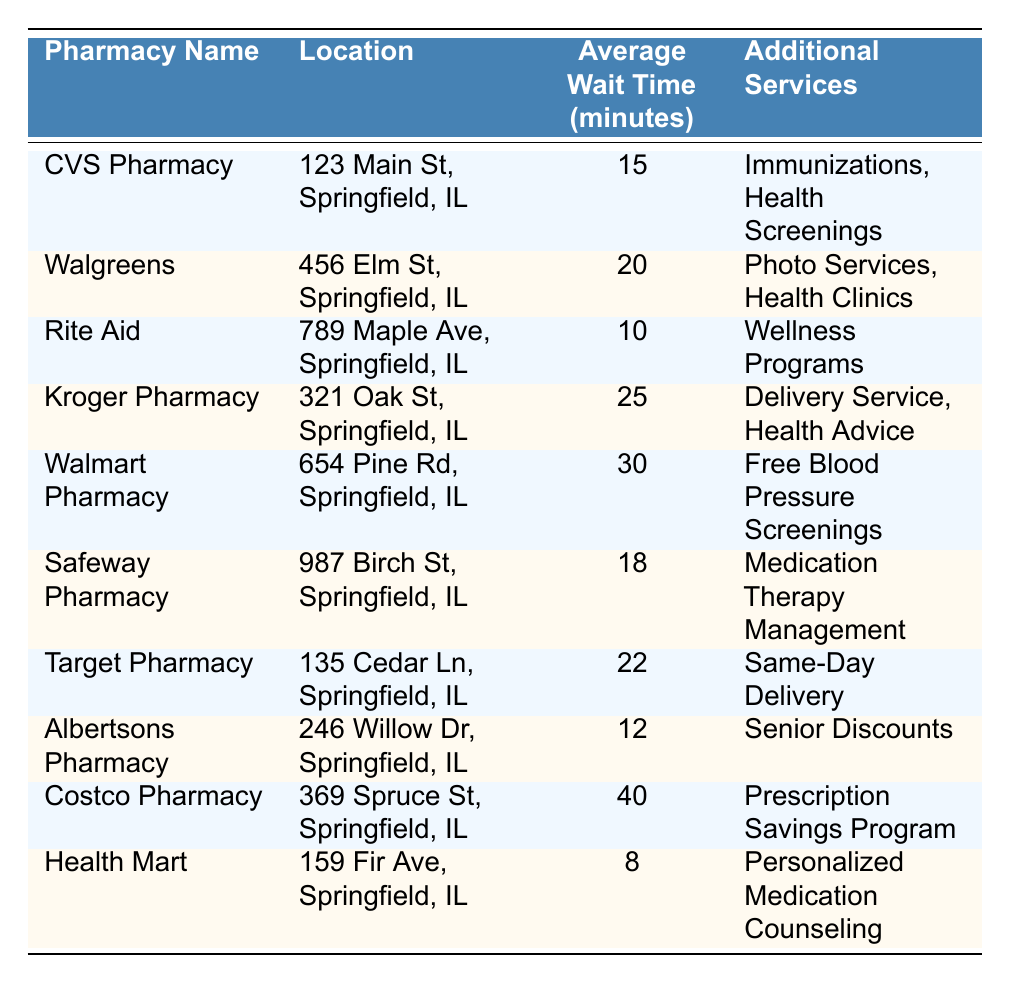What is the average wait time for picking up a prescription at Rite Aid? The table indicates that Rite Aid has an average wait time of 10 minutes for prescription pickup.
Answer: 10 minutes Which pharmacy has the longest average wait time? According to the table, Costco Pharmacy has the longest average wait time at 40 minutes.
Answer: Costco Pharmacy Which pharmacy offers the shortest average wait time? Health Mart offers the shortest average wait time of 8 minutes for prescription pickup.
Answer: Health Mart How much longer is the wait at Walmart Pharmacy compared to Albertsons Pharmacy? Walmart Pharmacy has an average wait time of 30 minutes, while Albertsons Pharmacy has a wait time of 12 minutes. The difference is 30 - 12 = 18 minutes.
Answer: 18 minutes Is the average wait time at Walgreens longer than at CVS Pharmacy? Yes, Walgreens has a wait time of 20 minutes, which is longer than CVS's 15 minutes.
Answer: Yes What is the average wait time for all pharmacies listed? To find the average, sum all the wait times: 15 + 20 + 10 + 25 + 30 + 18 + 22 + 12 + 40 + 8 = 210. There are 10 pharmacies, so the average is 210 / 10 = 21 minutes.
Answer: 21 minutes How many pharmacies have an average wait time of 20 minutes or less? The pharmacies with 20 minutes or less wait times are CVS (15 min), Rite Aid (10 min), Albertsons (12 min), and Health Mart (8 min). That totals 4 pharmacies.
Answer: 4 pharmacies Which pharmacy provides additional services related to senior citizens? Albertsons Pharmacy offers senior discounts among its additional services.
Answer: Albertsons Pharmacy Is the average wait time at Safeway Pharmacy more than 20 minutes? No, Safeway Pharmacy has an average wait time of 18 minutes, which is less than 20 minutes.
Answer: No What percentage of pharmacies have wait times greater than 20 minutes? There are 4 pharmacies with wait times greater than 20 minutes (Kroger, Walmart, Target, and Costco) out of 10 total pharmacies. The percentage is (4 / 10) * 100 = 40%.
Answer: 40% 